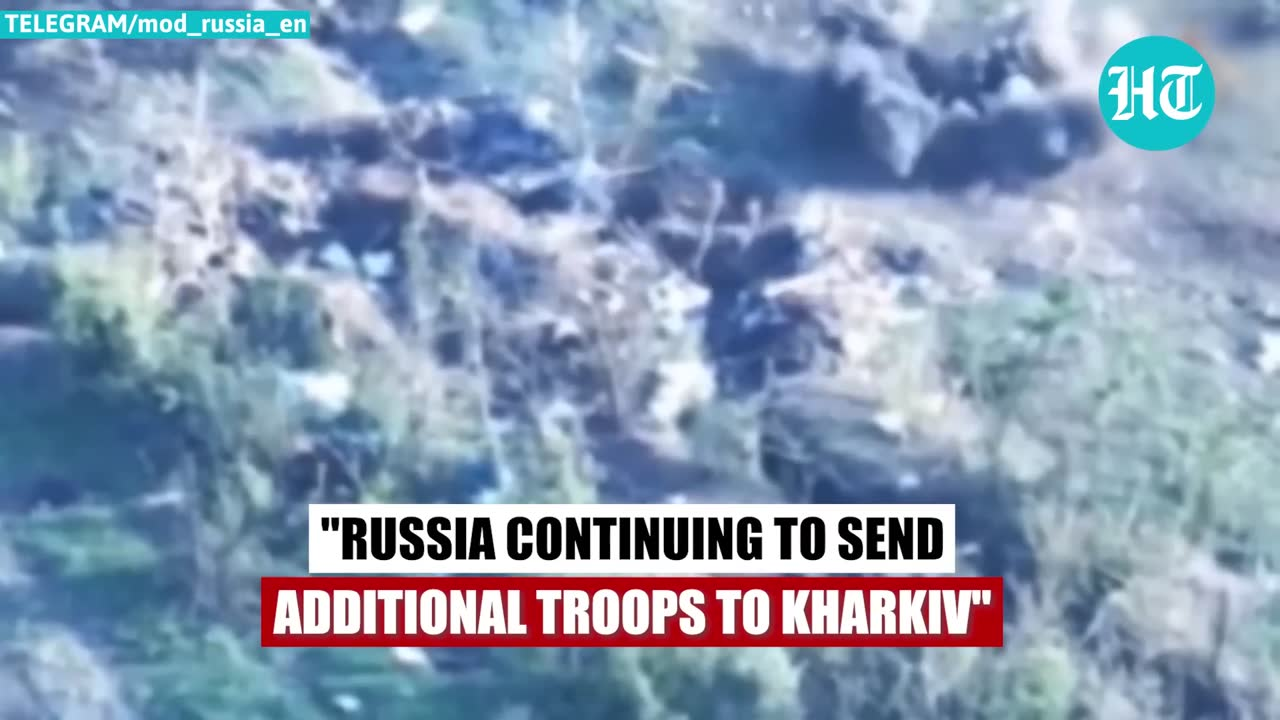describe the img The image appears to show an aerial view of a cloudy, overcast sky. There are no human faces or individuals visible in the image. The text overlay on the image states "Russia continuing to send additional troops to Kharkiv", indicating that the focus of the image is on Russian military activity in the Kharkiv region. 